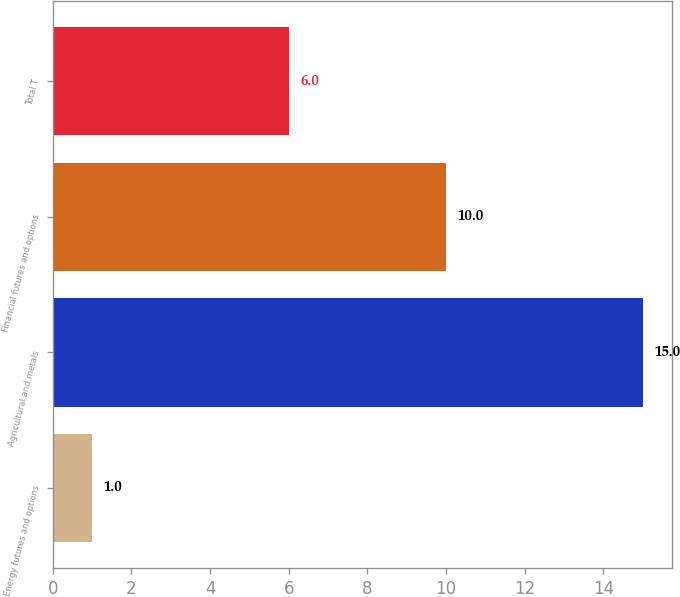<chart> <loc_0><loc_0><loc_500><loc_500><bar_chart><fcel>Energy futures and options<fcel>Agricultural and metals<fcel>Financial futures and options<fcel>Total T<nl><fcel>1<fcel>15<fcel>10<fcel>6<nl></chart> 